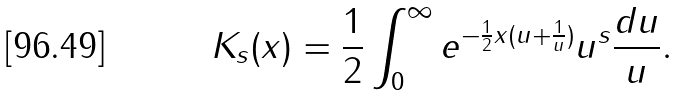<formula> <loc_0><loc_0><loc_500><loc_500>K _ { s } ( x ) = \frac { 1 } { 2 } \int _ { 0 } ^ { \infty } e ^ { - \frac { 1 } { 2 } x ( u + \frac { 1 } { u } ) } u ^ { s } \frac { d u } { u } .</formula> 